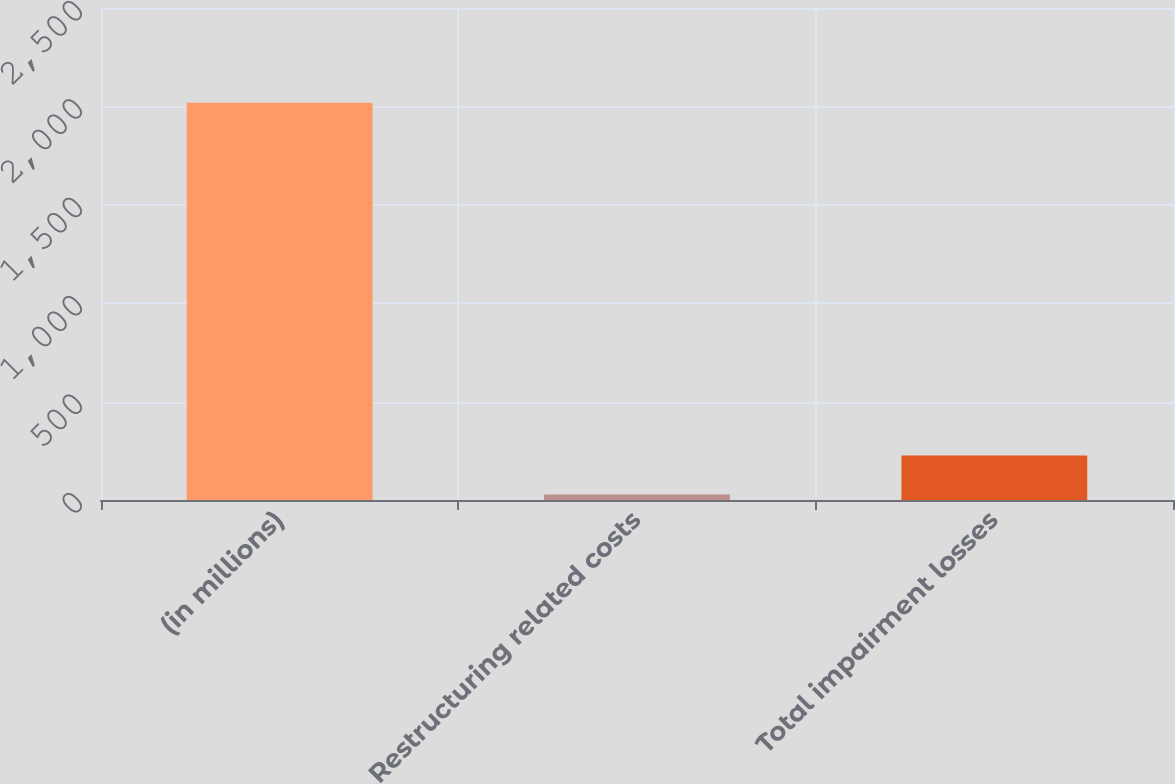Convert chart. <chart><loc_0><loc_0><loc_500><loc_500><bar_chart><fcel>(in millions)<fcel>Restructuring related costs<fcel>Total impairment losses<nl><fcel>2019<fcel>27.4<fcel>226.56<nl></chart> 